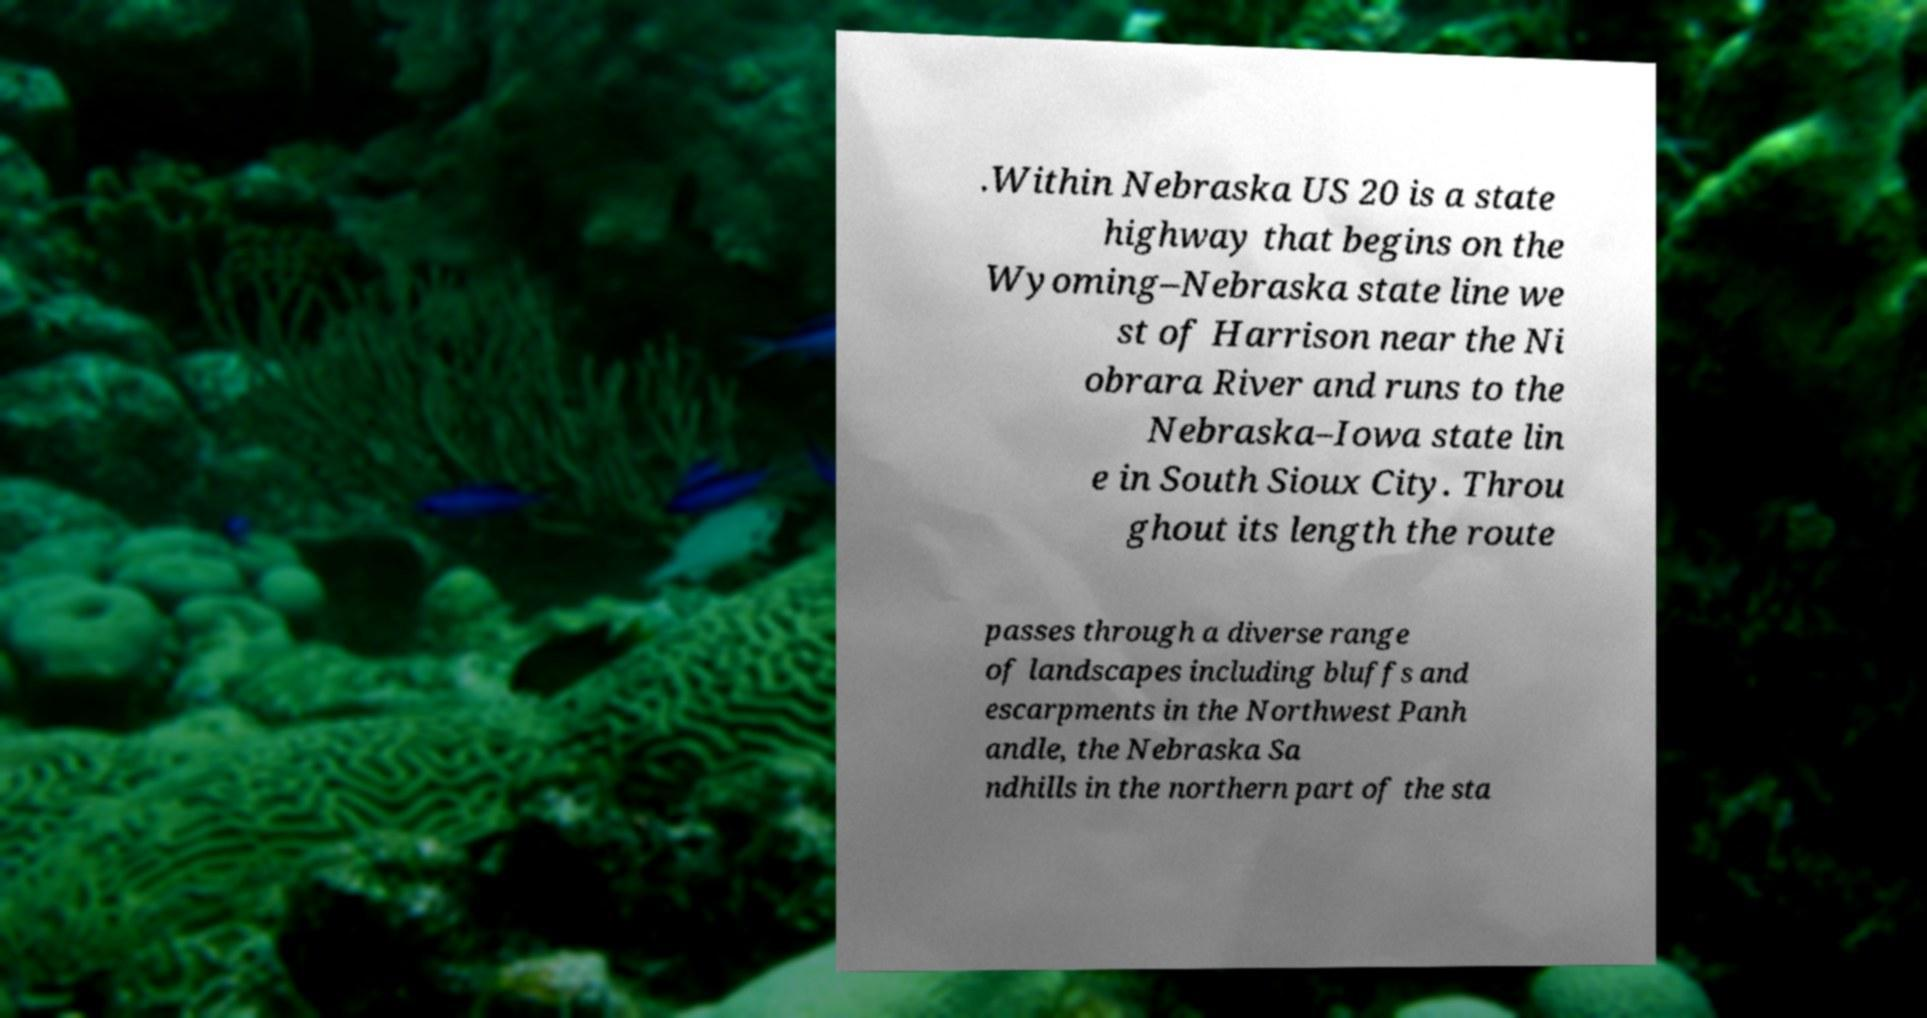Could you assist in decoding the text presented in this image and type it out clearly? .Within Nebraska US 20 is a state highway that begins on the Wyoming–Nebraska state line we st of Harrison near the Ni obrara River and runs to the Nebraska–Iowa state lin e in South Sioux City. Throu ghout its length the route passes through a diverse range of landscapes including bluffs and escarpments in the Northwest Panh andle, the Nebraska Sa ndhills in the northern part of the sta 